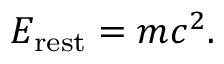<formula> <loc_0><loc_0><loc_500><loc_500>E _ { r e s t } = m c ^ { 2 } .</formula> 